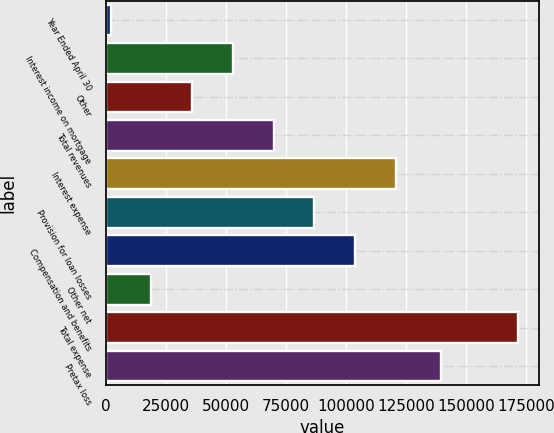Convert chart. <chart><loc_0><loc_0><loc_500><loc_500><bar_chart><fcel>Year Ended April 30<fcel>Interest income on mortgage<fcel>Other<fcel>Total revenues<fcel>Interest expense<fcel>Provision for loan losses<fcel>Compensation and benefits<fcel>Other net<fcel>Total expense<fcel>Pretax loss<nl><fcel>2011<fcel>52892.8<fcel>35932.2<fcel>69853.4<fcel>120735<fcel>86814<fcel>103775<fcel>18971.6<fcel>171617<fcel>139476<nl></chart> 